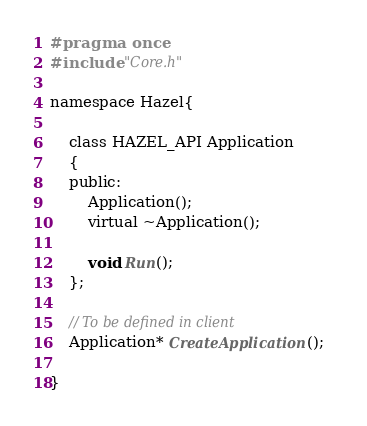Convert code to text. <code><loc_0><loc_0><loc_500><loc_500><_C_>#pragma once
#include "Core.h"

namespace Hazel{

	class HAZEL_API Application
	{
	public:
		Application();
		virtual ~Application();

		void Run();
	};

	// To be defined in client
	Application* CreateApplication();  

}</code> 